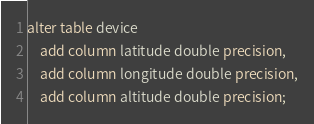Convert code to text. <code><loc_0><loc_0><loc_500><loc_500><_SQL_>alter table device
    add column latitude double precision,
    add column longitude double precision,
    add column altitude double precision;</code> 